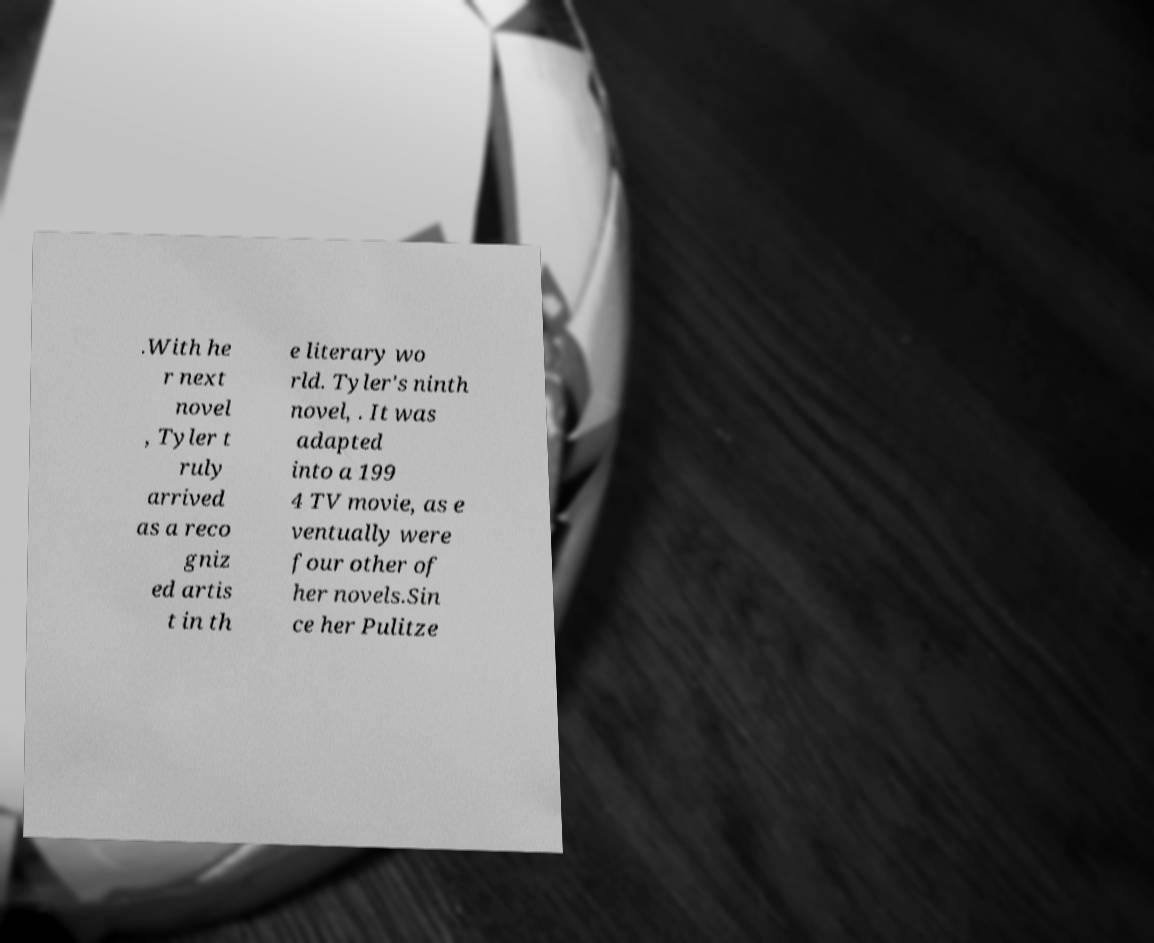Please identify and transcribe the text found in this image. .With he r next novel , Tyler t ruly arrived as a reco gniz ed artis t in th e literary wo rld. Tyler's ninth novel, . It was adapted into a 199 4 TV movie, as e ventually were four other of her novels.Sin ce her Pulitze 